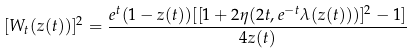<formula> <loc_0><loc_0><loc_500><loc_500>[ W _ { t } ( z ( t ) ) ] ^ { 2 } = \frac { e ^ { t } ( 1 - z ( t ) ) [ [ 1 + 2 \eta ( 2 t , e ^ { - t } \lambda ( z ( t ) ) ) ] ^ { 2 } - 1 ] } { 4 z ( t ) }</formula> 